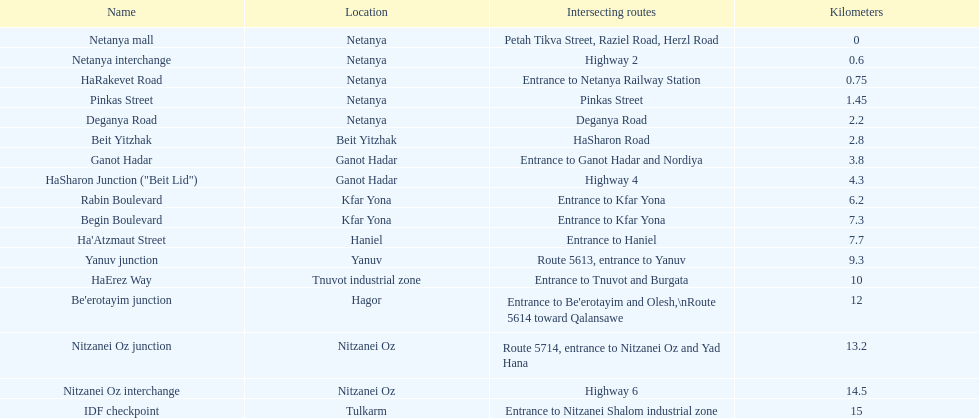What are all of the different portions? Netanya mall, Netanya interchange, HaRakevet Road, Pinkas Street, Deganya Road, Beit Yitzhak, Ganot Hadar, HaSharon Junction ("Beit Lid"), Rabin Boulevard, Begin Boulevard, Ha'Atzmaut Street, Yanuv junction, HaErez Way, Be'erotayim junction, Nitzanei Oz junction, Nitzanei Oz interchange, IDF checkpoint. What is the intersecting route for rabin boulevard? Entrance to Kfar Yona. What portion also has an intersecting route of entrance to kfar yona? Begin Boulevard. 